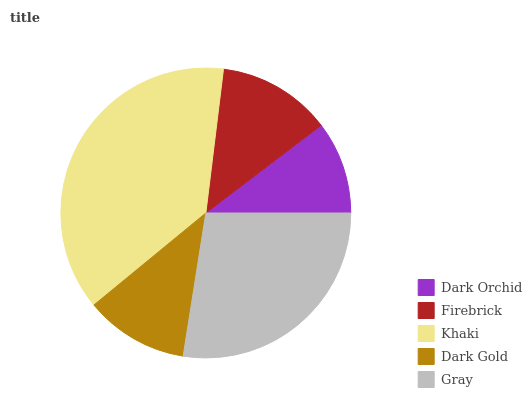Is Dark Orchid the minimum?
Answer yes or no. Yes. Is Khaki the maximum?
Answer yes or no. Yes. Is Firebrick the minimum?
Answer yes or no. No. Is Firebrick the maximum?
Answer yes or no. No. Is Firebrick greater than Dark Orchid?
Answer yes or no. Yes. Is Dark Orchid less than Firebrick?
Answer yes or no. Yes. Is Dark Orchid greater than Firebrick?
Answer yes or no. No. Is Firebrick less than Dark Orchid?
Answer yes or no. No. Is Firebrick the high median?
Answer yes or no. Yes. Is Firebrick the low median?
Answer yes or no. Yes. Is Dark Orchid the high median?
Answer yes or no. No. Is Gray the low median?
Answer yes or no. No. 